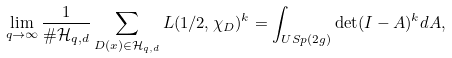<formula> <loc_0><loc_0><loc_500><loc_500>\lim _ { q \to \infty } \frac { 1 } { \# \mathcal { H } _ { q , d } } \sum _ { D ( x ) \in \mathcal { H } _ { q , d } } L ( 1 / 2 , \chi _ { D } ) ^ { k } = \int _ { U S p ( 2 g ) } \det ( I - A ) ^ { k } d A ,</formula> 